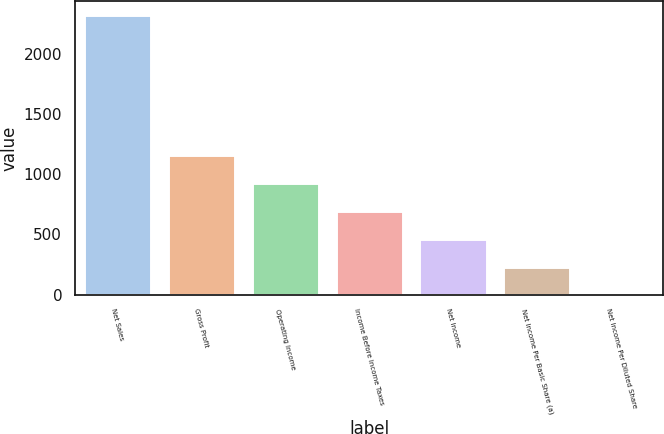Convert chart to OTSL. <chart><loc_0><loc_0><loc_500><loc_500><bar_chart><fcel>Net Sales<fcel>Gross Profit<fcel>Operating Income<fcel>Income Before Income Taxes<fcel>Net Income<fcel>Net Income Per Basic Share (a)<fcel>Net Income Per Diluted Share<nl><fcel>2319<fcel>1159.74<fcel>927.88<fcel>696.02<fcel>464.16<fcel>232.3<fcel>0.44<nl></chart> 